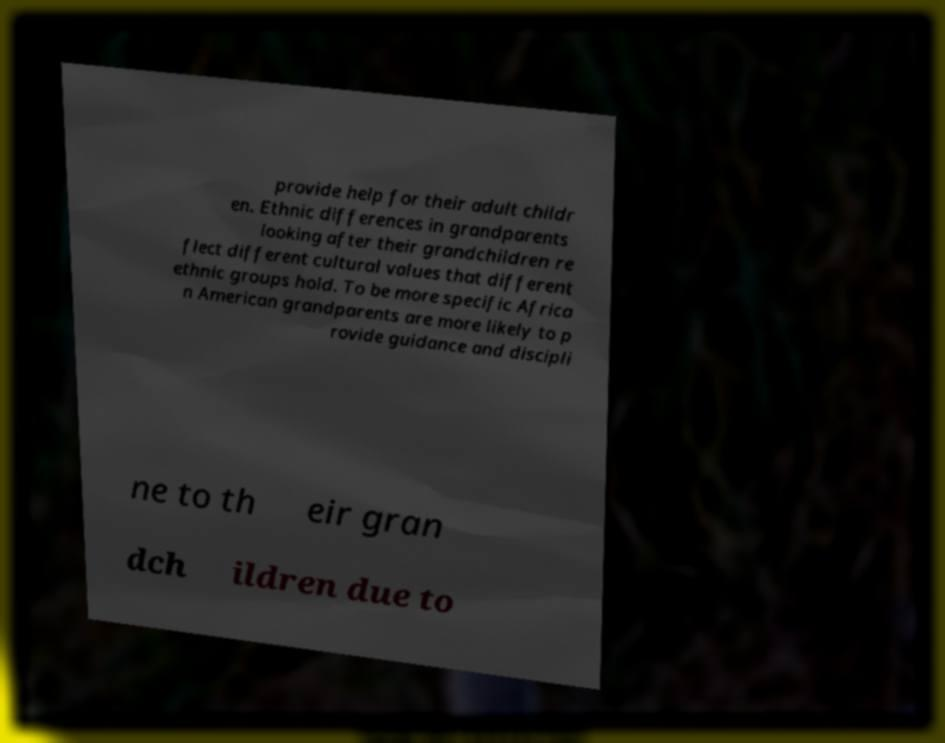Could you assist in decoding the text presented in this image and type it out clearly? provide help for their adult childr en. Ethnic differences in grandparents looking after their grandchildren re flect different cultural values that different ethnic groups hold. To be more specific Africa n American grandparents are more likely to p rovide guidance and discipli ne to th eir gran dch ildren due to 